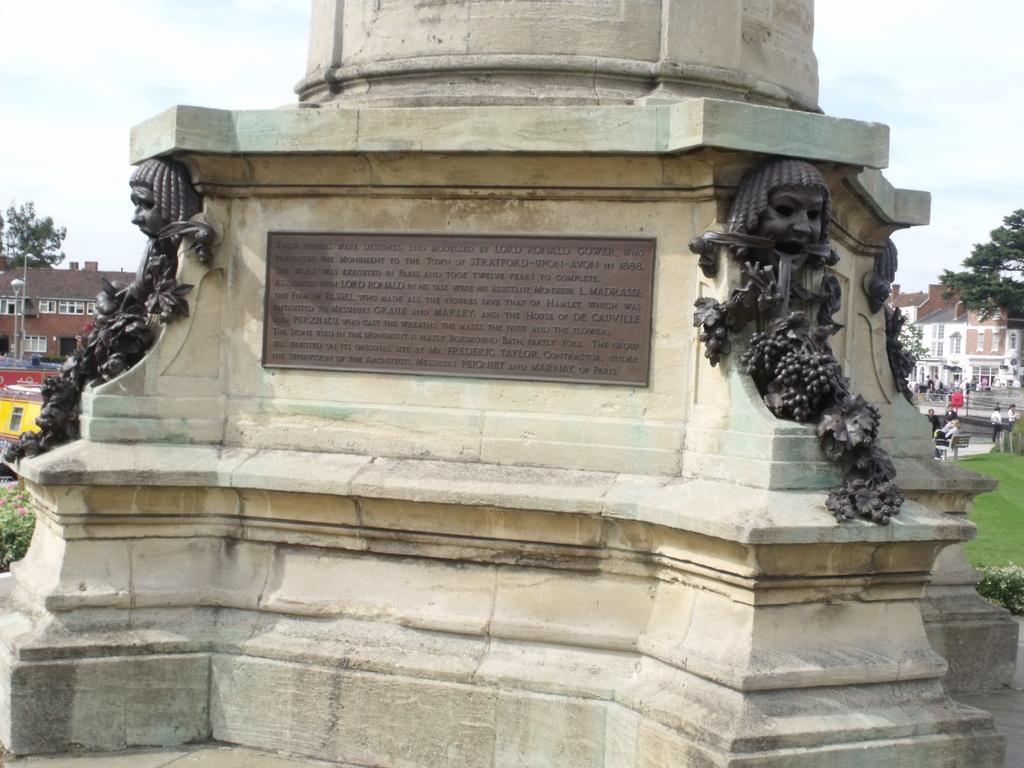Can you describe this image briefly? In this image there is a pillar and there are two sculptures on either side of the pillar. In the middle there is a text. In the background there are buildings. At the top there is sky. 